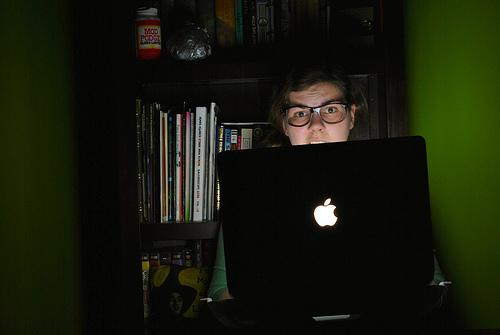Describe the colors and objects visible in the background of the image. The background features a bookshelf behind the person with various items on it, a green wall on the side, and the main object, a woman using a laptop in front of the shelf. How many books are visible on the bookcase and what other objects are present? There are at least three sets of books visible on the bookshelf, along with a jar, a red jar with a white lid, a black and yellow pillow, a ball of grey duct tape, a bottle, a bag, and an unidentified object. What unique features can be found on the laptop in the image? The laptop is black with an apple and a white lit-up logo on it. Analyze the woman's interaction with the laptop and mention any facial features visible. The woman is looking straight ahead, wearing black glasses, and using a black laptop on her lap, with her eyes, nose, and ears visible. List the objects related to the main subject's appearance or clothing. Glasses, a green shirt, and black laptop are related to the main subject's appearance or clothing. Briefly depict the woman's appearance and the activity she is engaged in. A woman wearing black glasses and a green shirt is using a black laptop computer on her lap while looking straight ahead. What can you find on the bookshelf in the image? There are several books, a jar, a red jar with a white lid, a ball of grey duct tape, a bottle, a bag, a black and yellow pillow, and an object on the bookshelf. Can you identify the facial features of the person in the image? The person has glasses, left and right eyes, a nose, a left and right ear, and is looking at the camera with a woman's face. Estimate the number of books on the shelf and provide a general description of the shelf. There are roughly 15-20 books on the shelf, which is a black wooden surface with various other objects such as jars, a pillow, and a ball of duct tape. 